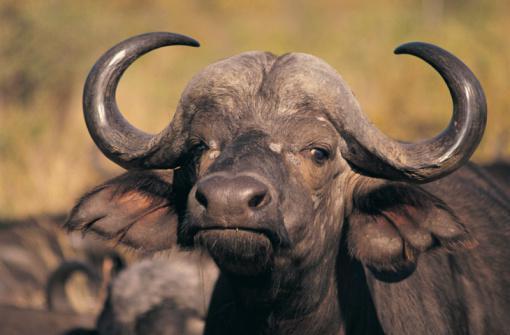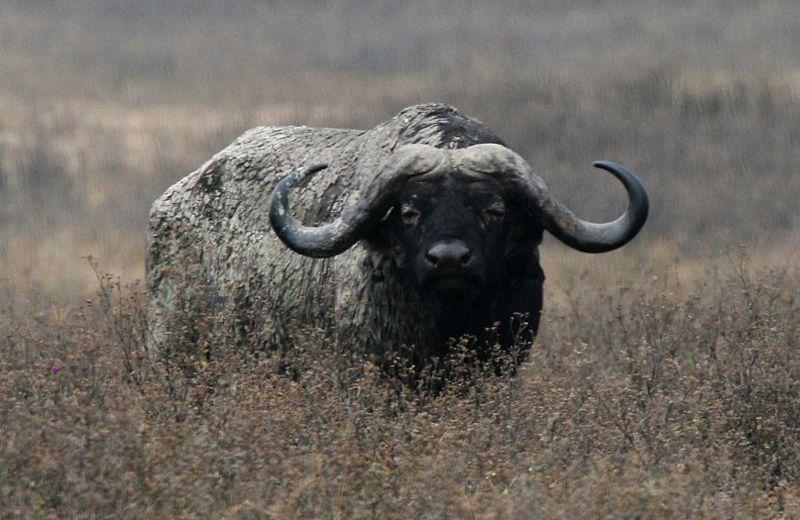The first image is the image on the left, the second image is the image on the right. Examine the images to the left and right. Is the description "Each image contains one water buffalo in the foreground who is looking directly ahead at the camera." accurate? Answer yes or no. Yes. 